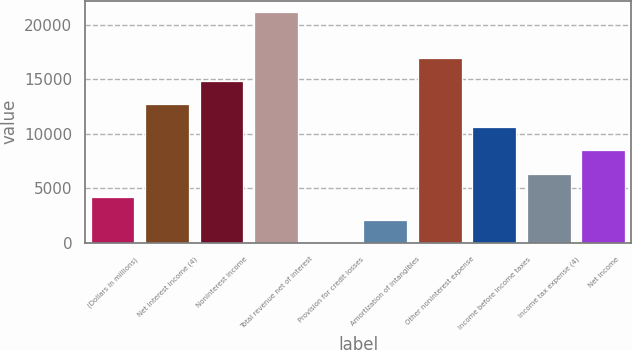Convert chart to OTSL. <chart><loc_0><loc_0><loc_500><loc_500><bar_chart><fcel>(Dollars in millions)<fcel>Net interest income (4)<fcel>Noninterest income<fcel>Total revenue net of interest<fcel>Provision for credit losses<fcel>Amortization of intangibles<fcel>Other noninterest expense<fcel>Income before income taxes<fcel>Income tax expense (4)<fcel>Net income<nl><fcel>4239.4<fcel>12700.2<fcel>14815.4<fcel>21161<fcel>9<fcel>2124.2<fcel>16930.6<fcel>10585<fcel>6354.6<fcel>8469.8<nl></chart> 